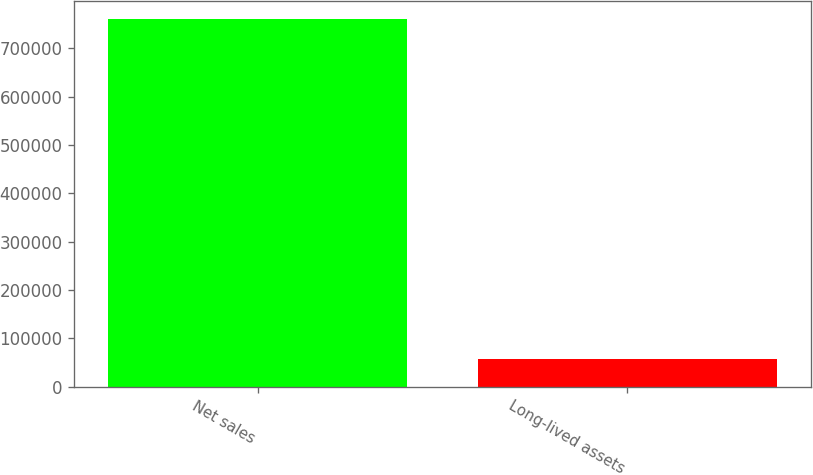Convert chart. <chart><loc_0><loc_0><loc_500><loc_500><bar_chart><fcel>Net sales<fcel>Long-lived assets<nl><fcel>759524<fcel>57431<nl></chart> 